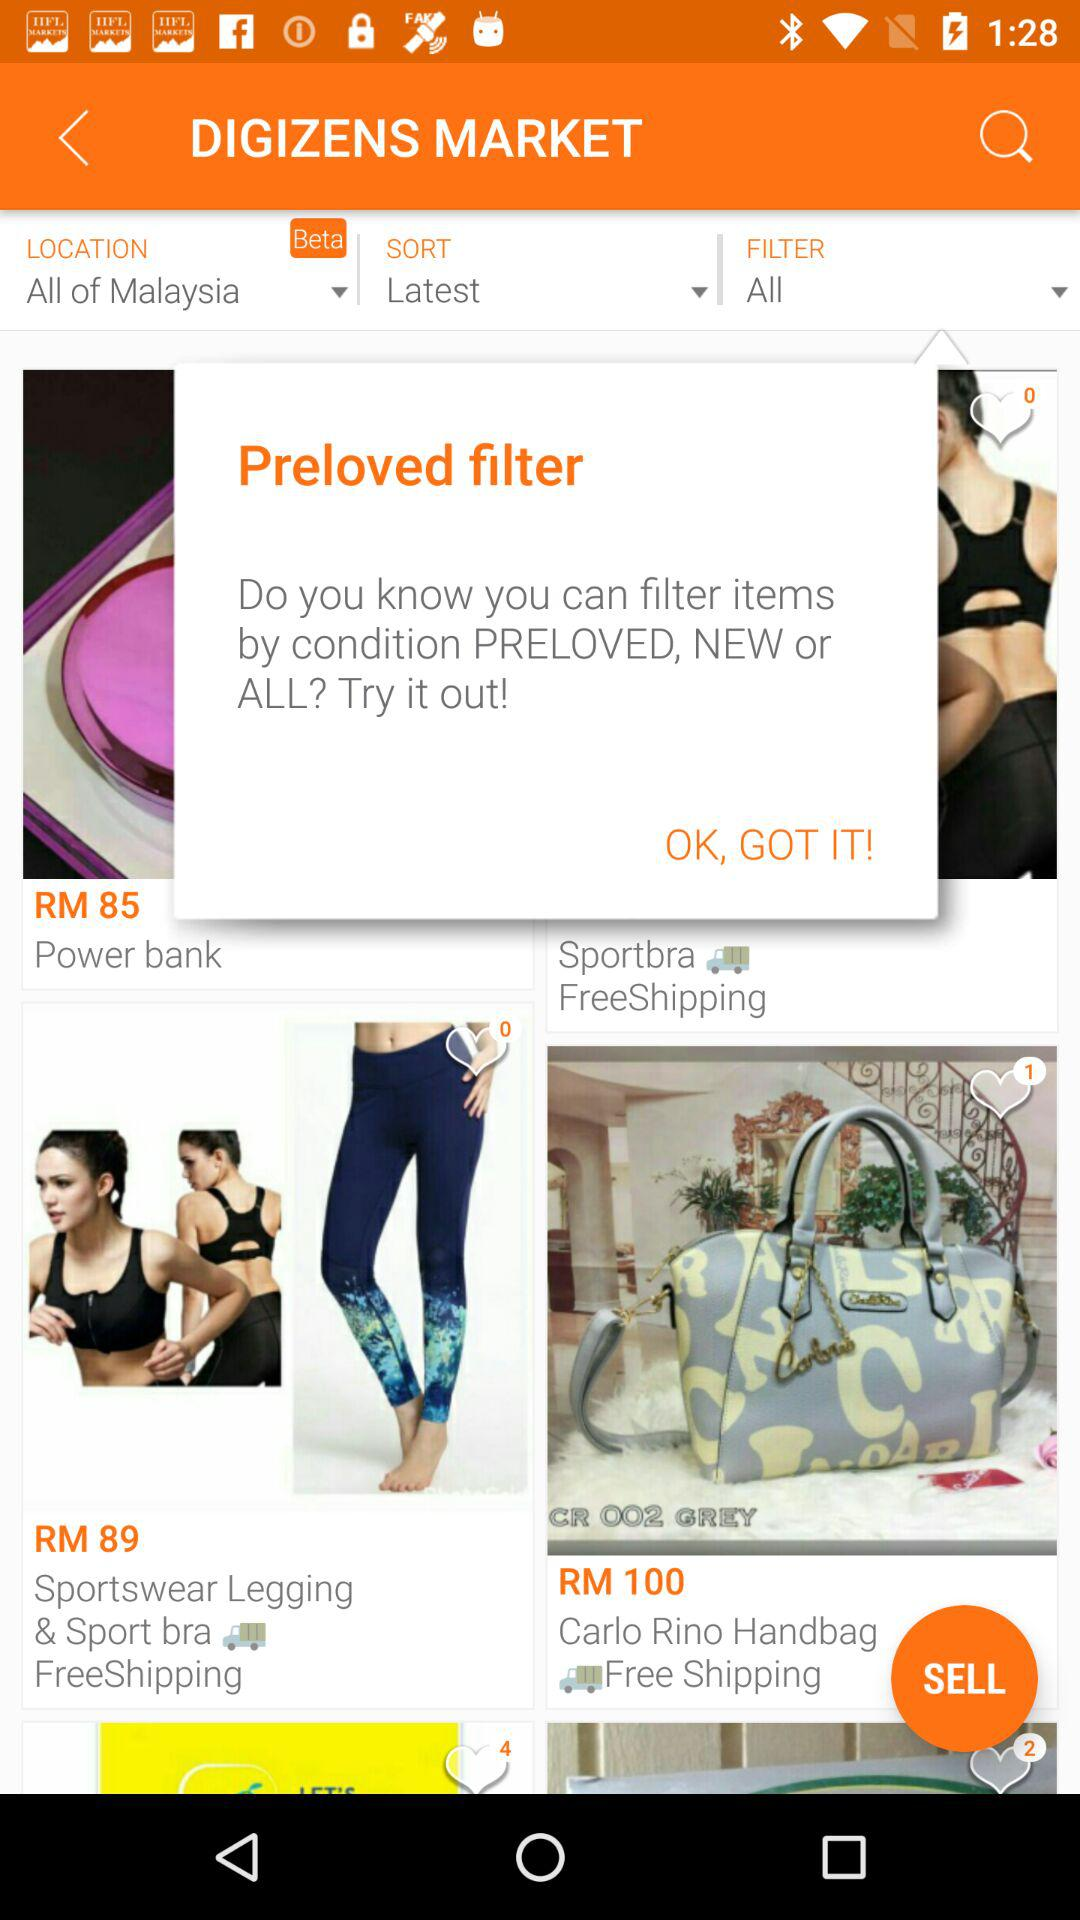Which location is selected? The location is "All of Malaysia". 